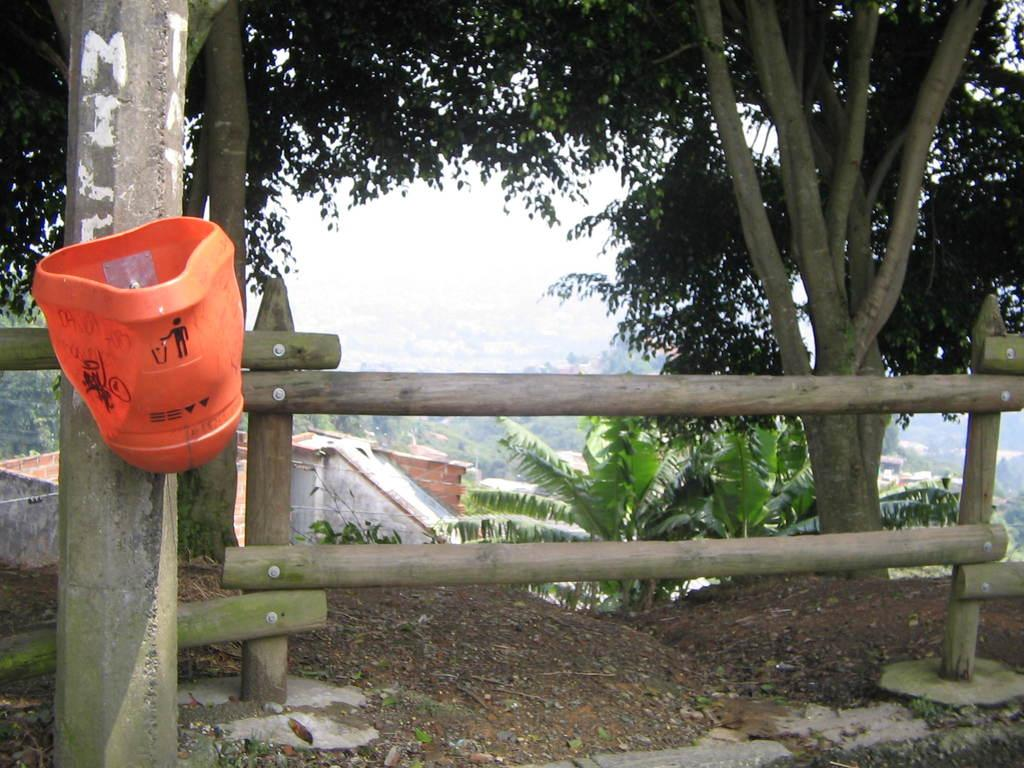What type of vegetation can be seen in the image? There are trees in the image. What type of barrier is present in the image? There is a fence in the image. What is attached to the pole in the image? There is a red object attached to the pole in the image. What type of structures can be seen in the image? There are buildings in the image. What is visible in the background of the image? The sky is visible in the background of the image. Can you hear the bell ringing in the image? There is no bell present in the image, so it cannot be heard. What type of spade is being used to dig in the image? There is no spade present in the image, so it cannot be used for digging. 